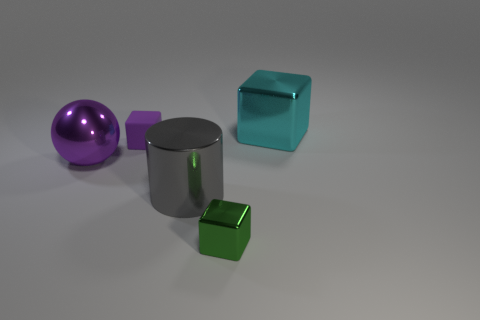What could be the purpose of these objects? These objects seem to be 3D models and likely serve as part of a visualization or a rendering test to showcase different material properties, shapes, and lighting effects. In a practical context, they don't appear to serve a specific purpose other than visual demonstration. 